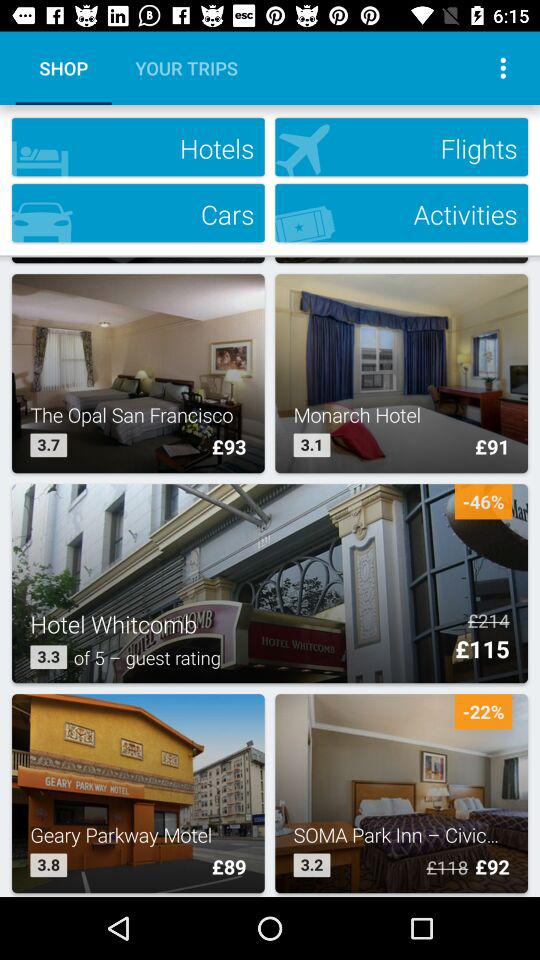How much is the discount for "Hotel Whitcomb"? The discount for "Hotel Whitcomb" in percentage is 46. 